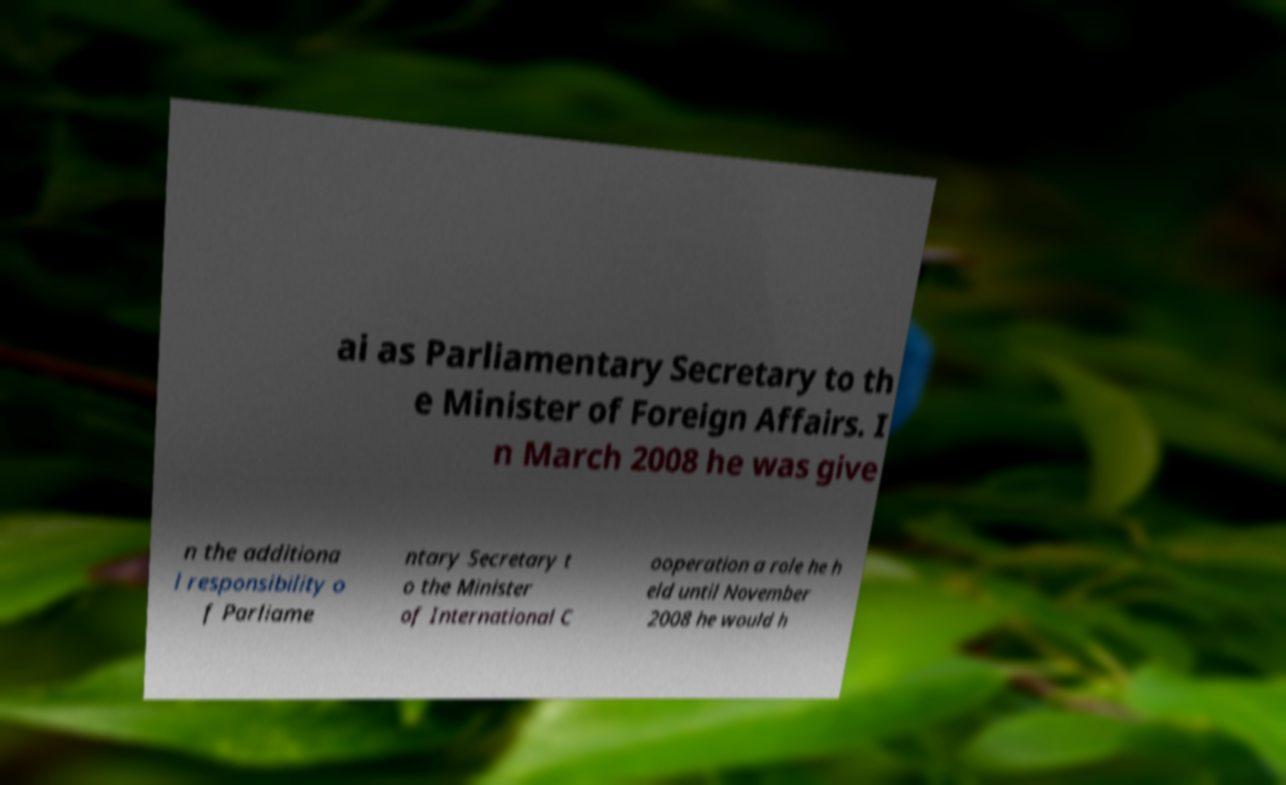For documentation purposes, I need the text within this image transcribed. Could you provide that? ai as Parliamentary Secretary to th e Minister of Foreign Affairs. I n March 2008 he was give n the additiona l responsibility o f Parliame ntary Secretary t o the Minister of International C ooperation a role he h eld until November 2008 he would h 